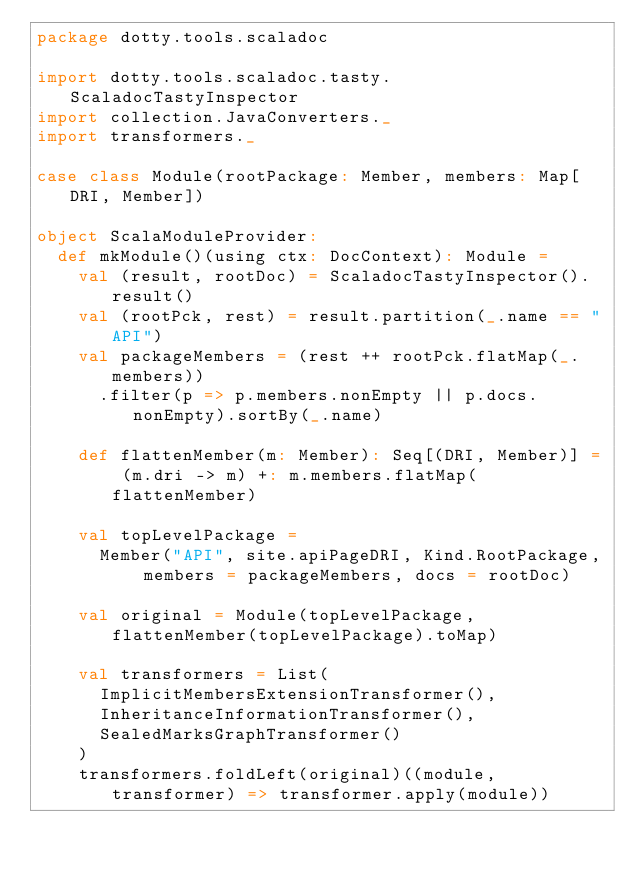<code> <loc_0><loc_0><loc_500><loc_500><_Scala_>package dotty.tools.scaladoc

import dotty.tools.scaladoc.tasty.ScaladocTastyInspector
import collection.JavaConverters._
import transformers._

case class Module(rootPackage: Member, members: Map[DRI, Member])

object ScalaModuleProvider:
  def mkModule()(using ctx: DocContext): Module =
    val (result, rootDoc) = ScaladocTastyInspector().result()
    val (rootPck, rest) = result.partition(_.name == "API")
    val packageMembers = (rest ++ rootPck.flatMap(_.members))
      .filter(p => p.members.nonEmpty || p.docs.nonEmpty).sortBy(_.name)

    def flattenMember(m: Member): Seq[(DRI, Member)] = (m.dri -> m) +: m.members.flatMap(flattenMember)

    val topLevelPackage =
      Member("API", site.apiPageDRI, Kind.RootPackage, members = packageMembers, docs = rootDoc)

    val original = Module(topLevelPackage, flattenMember(topLevelPackage).toMap)

    val transformers = List(
      ImplicitMembersExtensionTransformer(),
      InheritanceInformationTransformer(),
      SealedMarksGraphTransformer()
    )
    transformers.foldLeft(original)((module, transformer) => transformer.apply(module))
</code> 